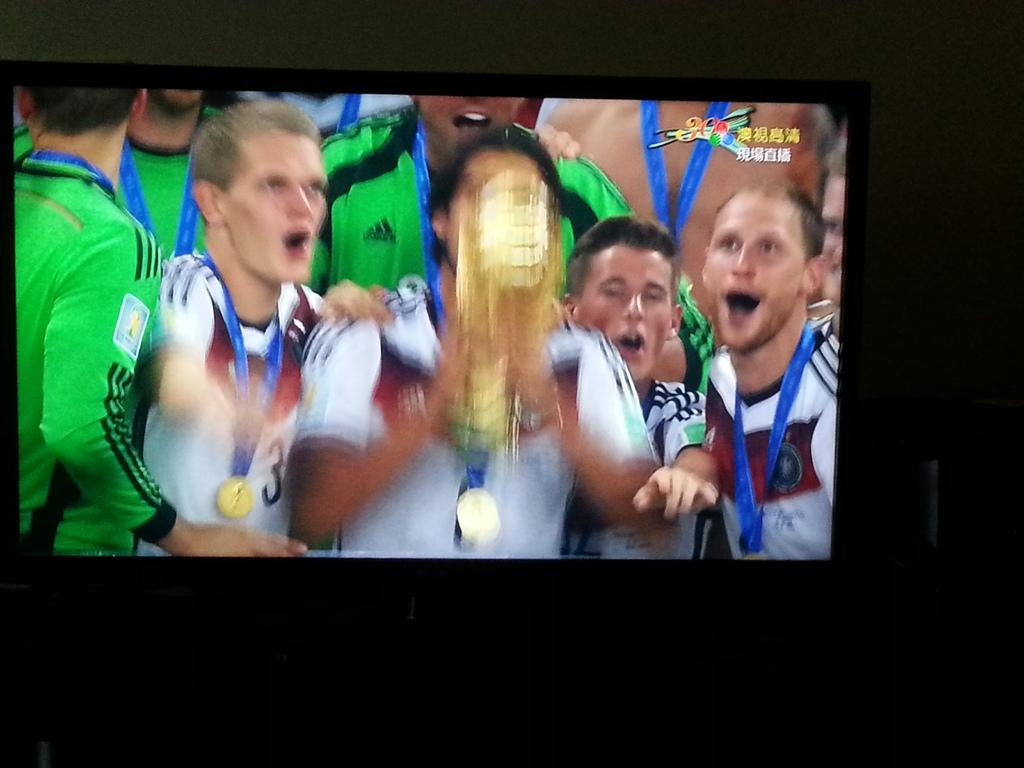What is the main object in the image? There is a screen in the image. What can be seen on the screen? There are people visible on the screen, along with a trophy and text. What is the background of the image? There is a wall in the background of the image. How many bulbs are used to light up the yard in the image? There is no yard or bulbs present in the image; it features a screen with people, a trophy, and text. What type of pleasure can be seen being experienced by the people on the screen? There is no indication of pleasure being experienced by the people on the screen; we can only see their presence and the trophy and text around them. 